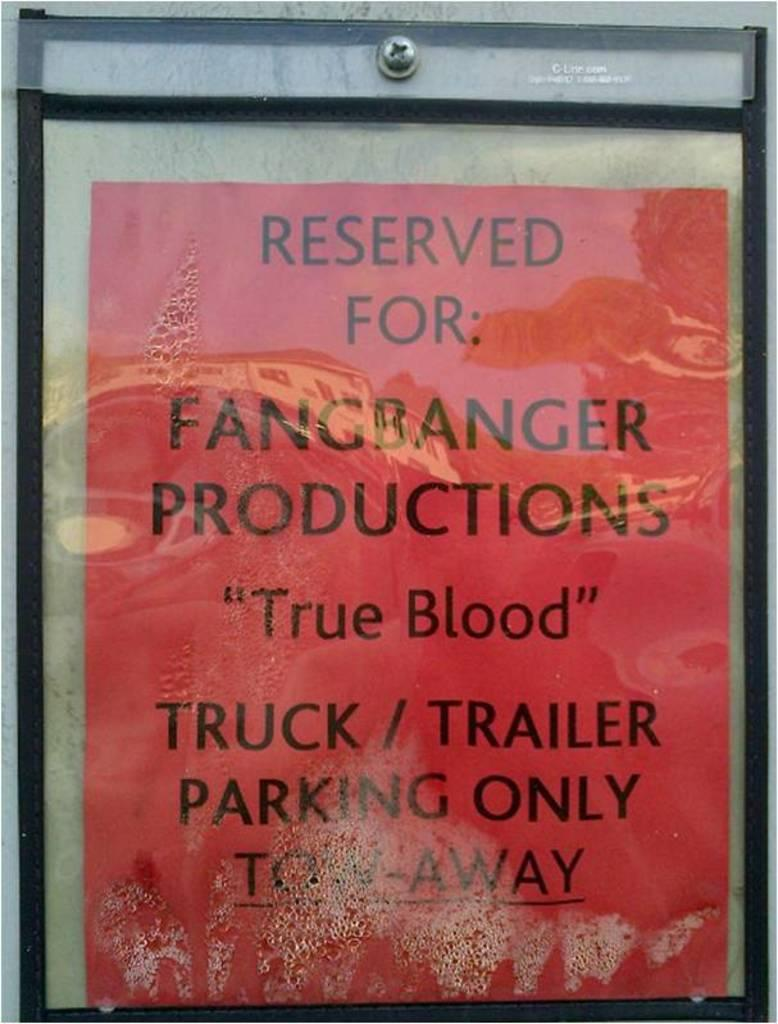<image>
Present a compact description of the photo's key features. a red advertisement with the word reserved at the top 